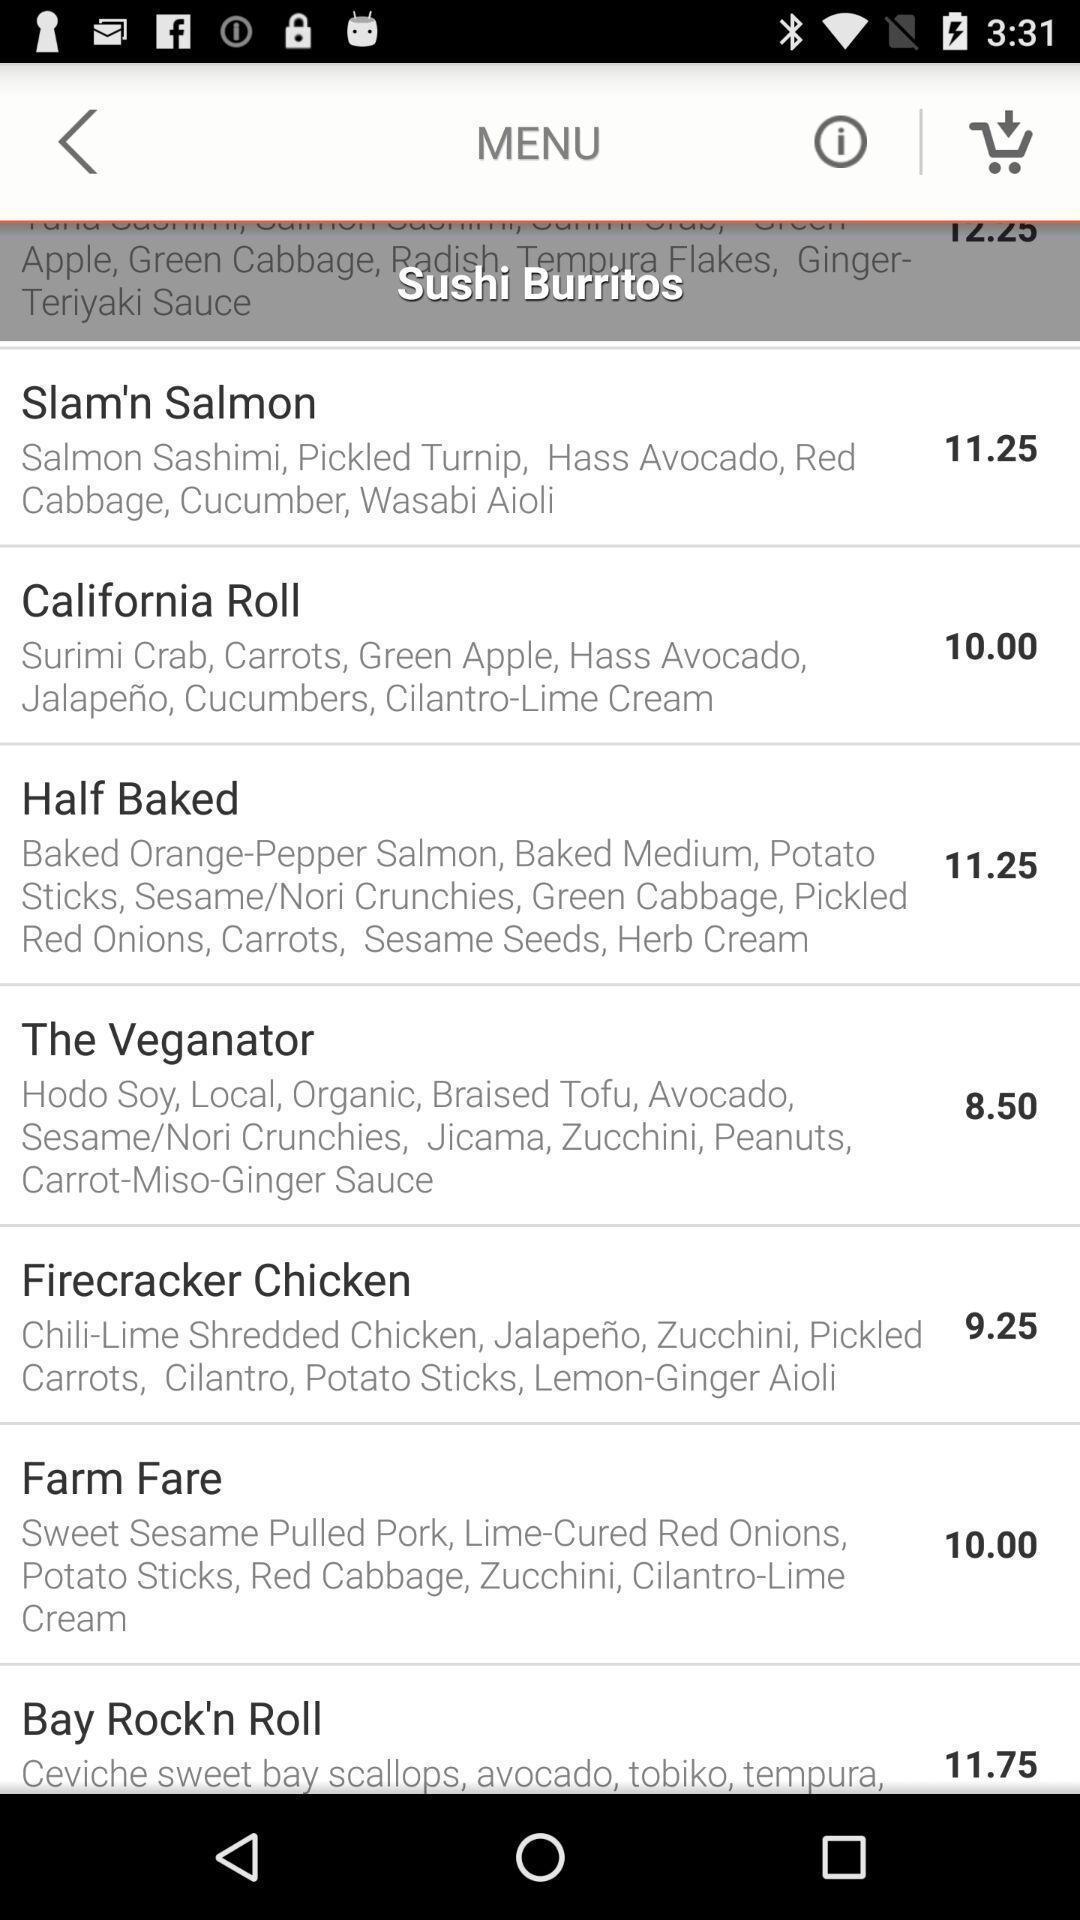Tell me what you see in this picture. Screen showing menu in an food application. 